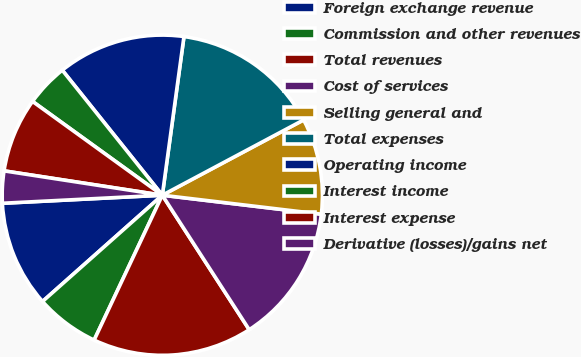Convert chart. <chart><loc_0><loc_0><loc_500><loc_500><pie_chart><fcel>Foreign exchange revenue<fcel>Commission and other revenues<fcel>Total revenues<fcel>Cost of services<fcel>Selling general and<fcel>Total expenses<fcel>Operating income<fcel>Interest income<fcel>Interest expense<fcel>Derivative (losses)/gains net<nl><fcel>10.75%<fcel>6.45%<fcel>16.13%<fcel>13.98%<fcel>9.68%<fcel>15.05%<fcel>12.9%<fcel>4.3%<fcel>7.53%<fcel>3.23%<nl></chart> 